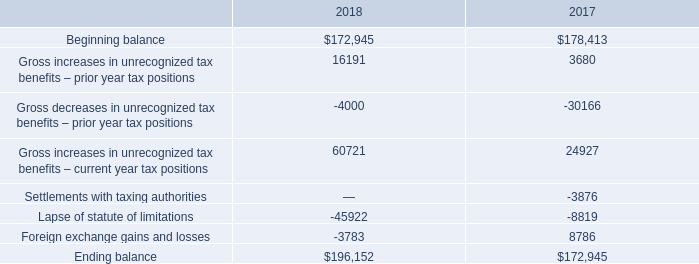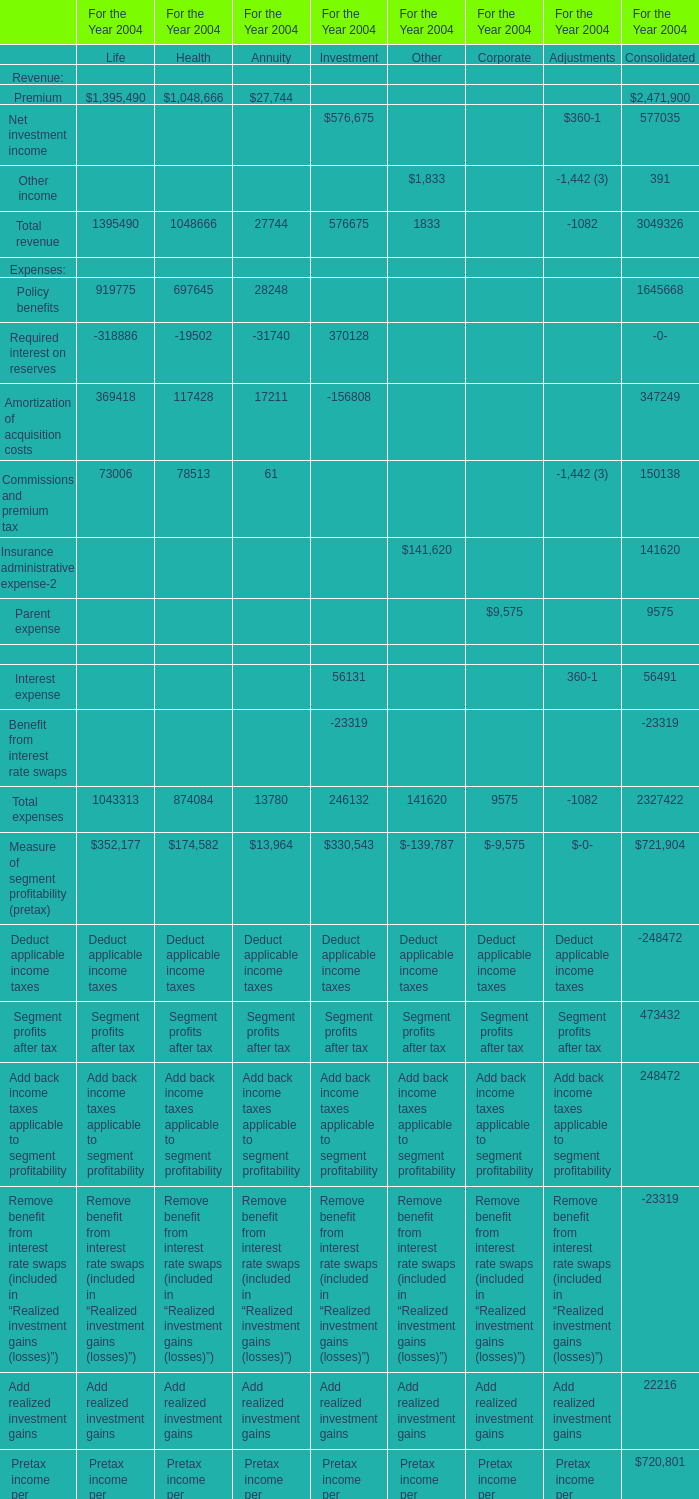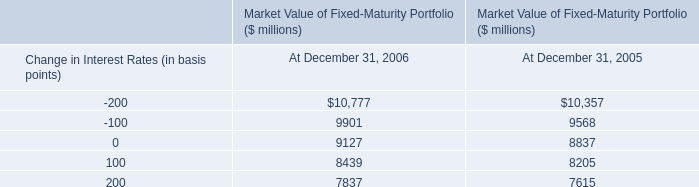What is the column number of the section where the Total revenue in 2004 is the most between Life,Health and Annuity? 
Answer: 1. 